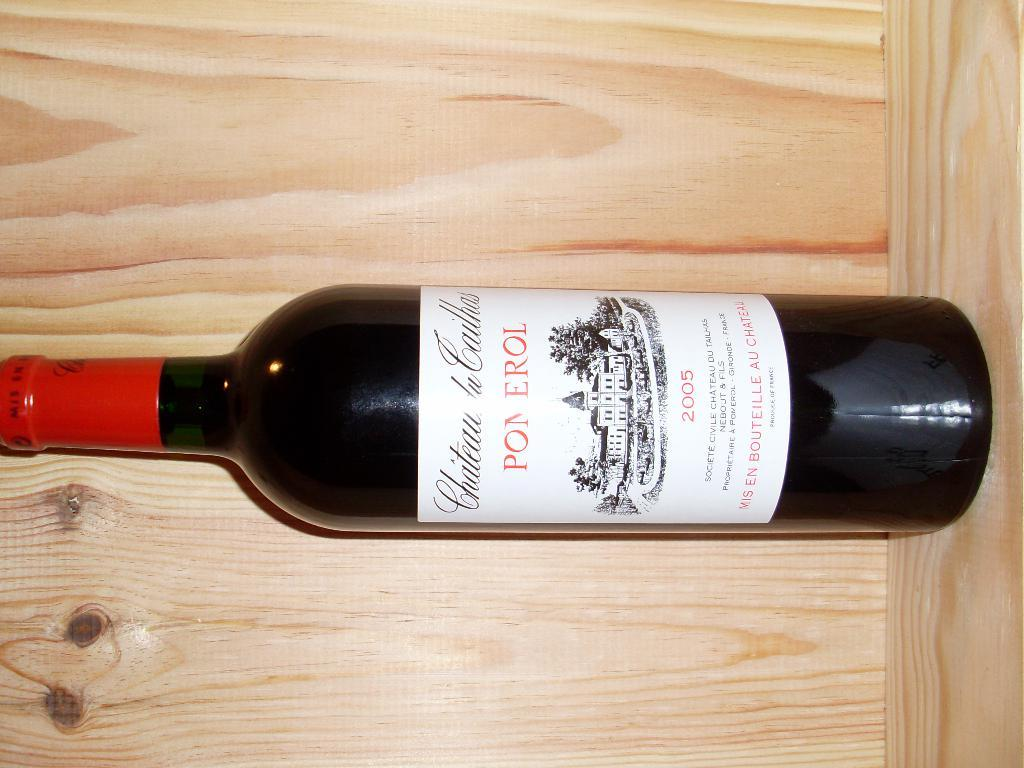<image>
Provide a brief description of the given image. a bottle of Pomerol wine 2005 in a wooden box 